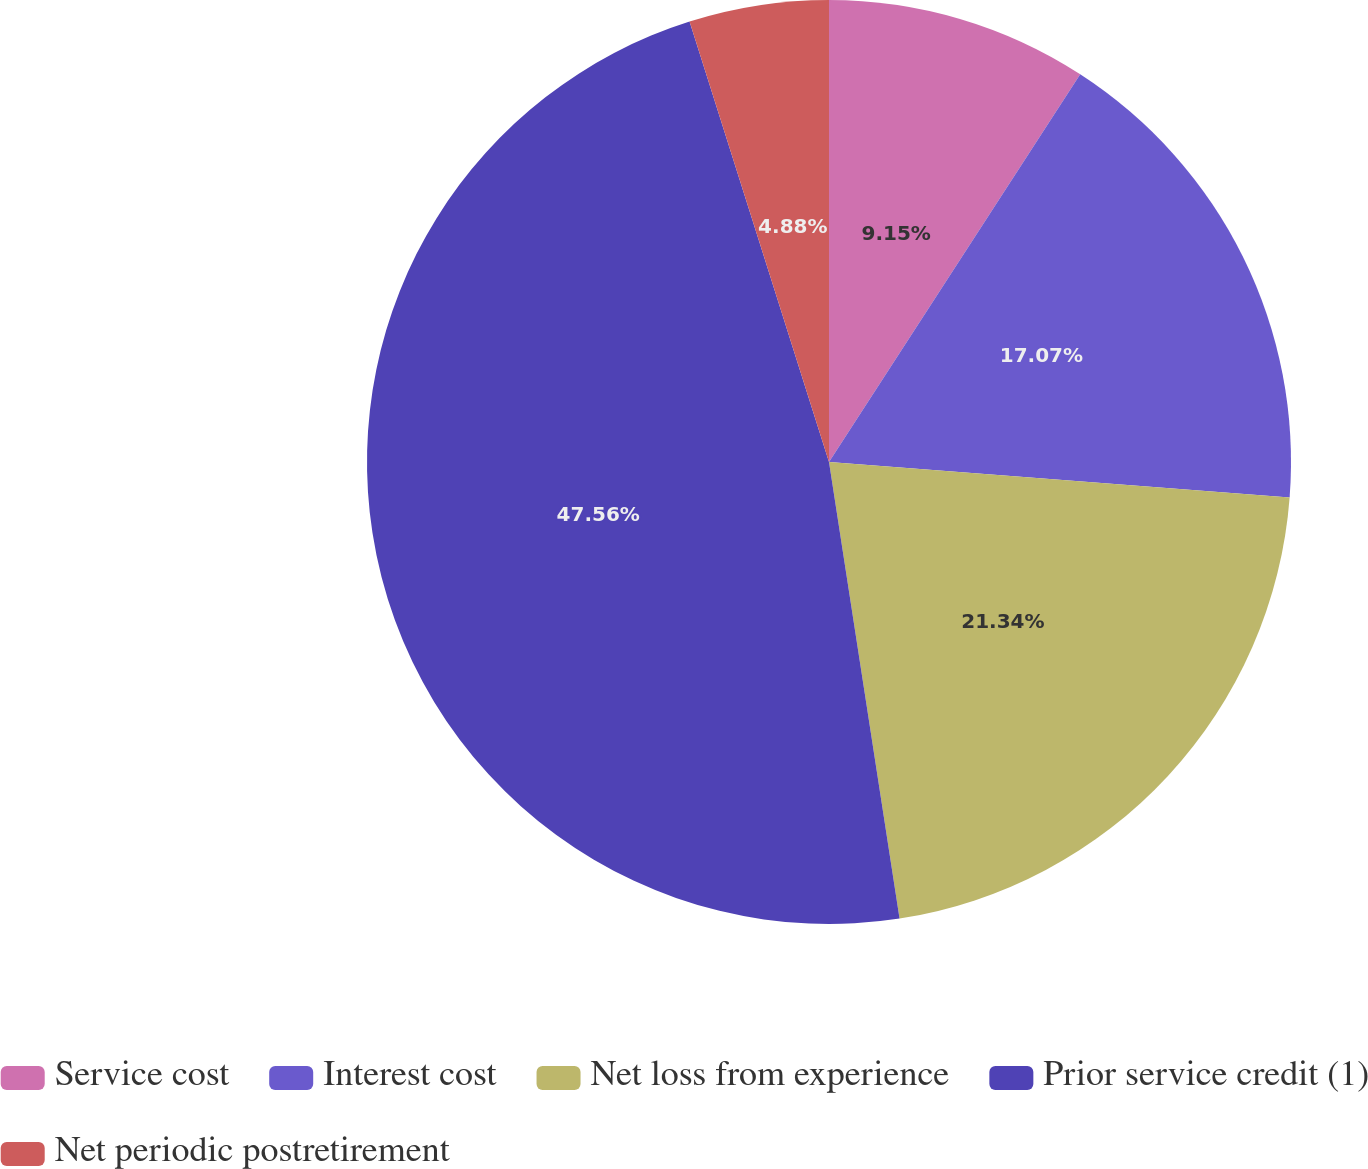Convert chart to OTSL. <chart><loc_0><loc_0><loc_500><loc_500><pie_chart><fcel>Service cost<fcel>Interest cost<fcel>Net loss from experience<fcel>Prior service credit (1)<fcel>Net periodic postretirement<nl><fcel>9.15%<fcel>17.07%<fcel>21.34%<fcel>47.56%<fcel>4.88%<nl></chart> 